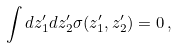<formula> <loc_0><loc_0><loc_500><loc_500>\int d z _ { 1 } ^ { \prime } d z _ { 2 } ^ { \prime } \sigma ( z _ { 1 } ^ { \prime } , z _ { 2 } ^ { \prime } ) = 0 \, ,</formula> 